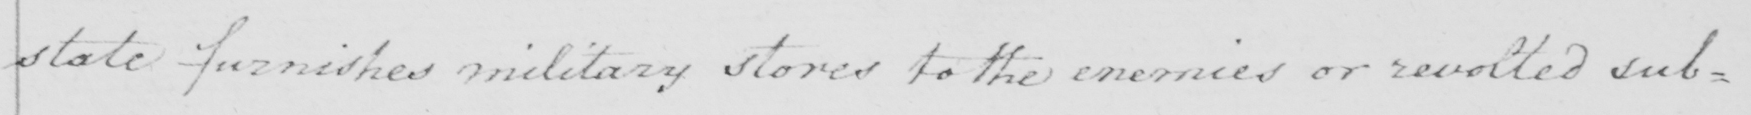Transcribe the text shown in this historical manuscript line. state furnishes military stores to the enemies or revolted sub= 